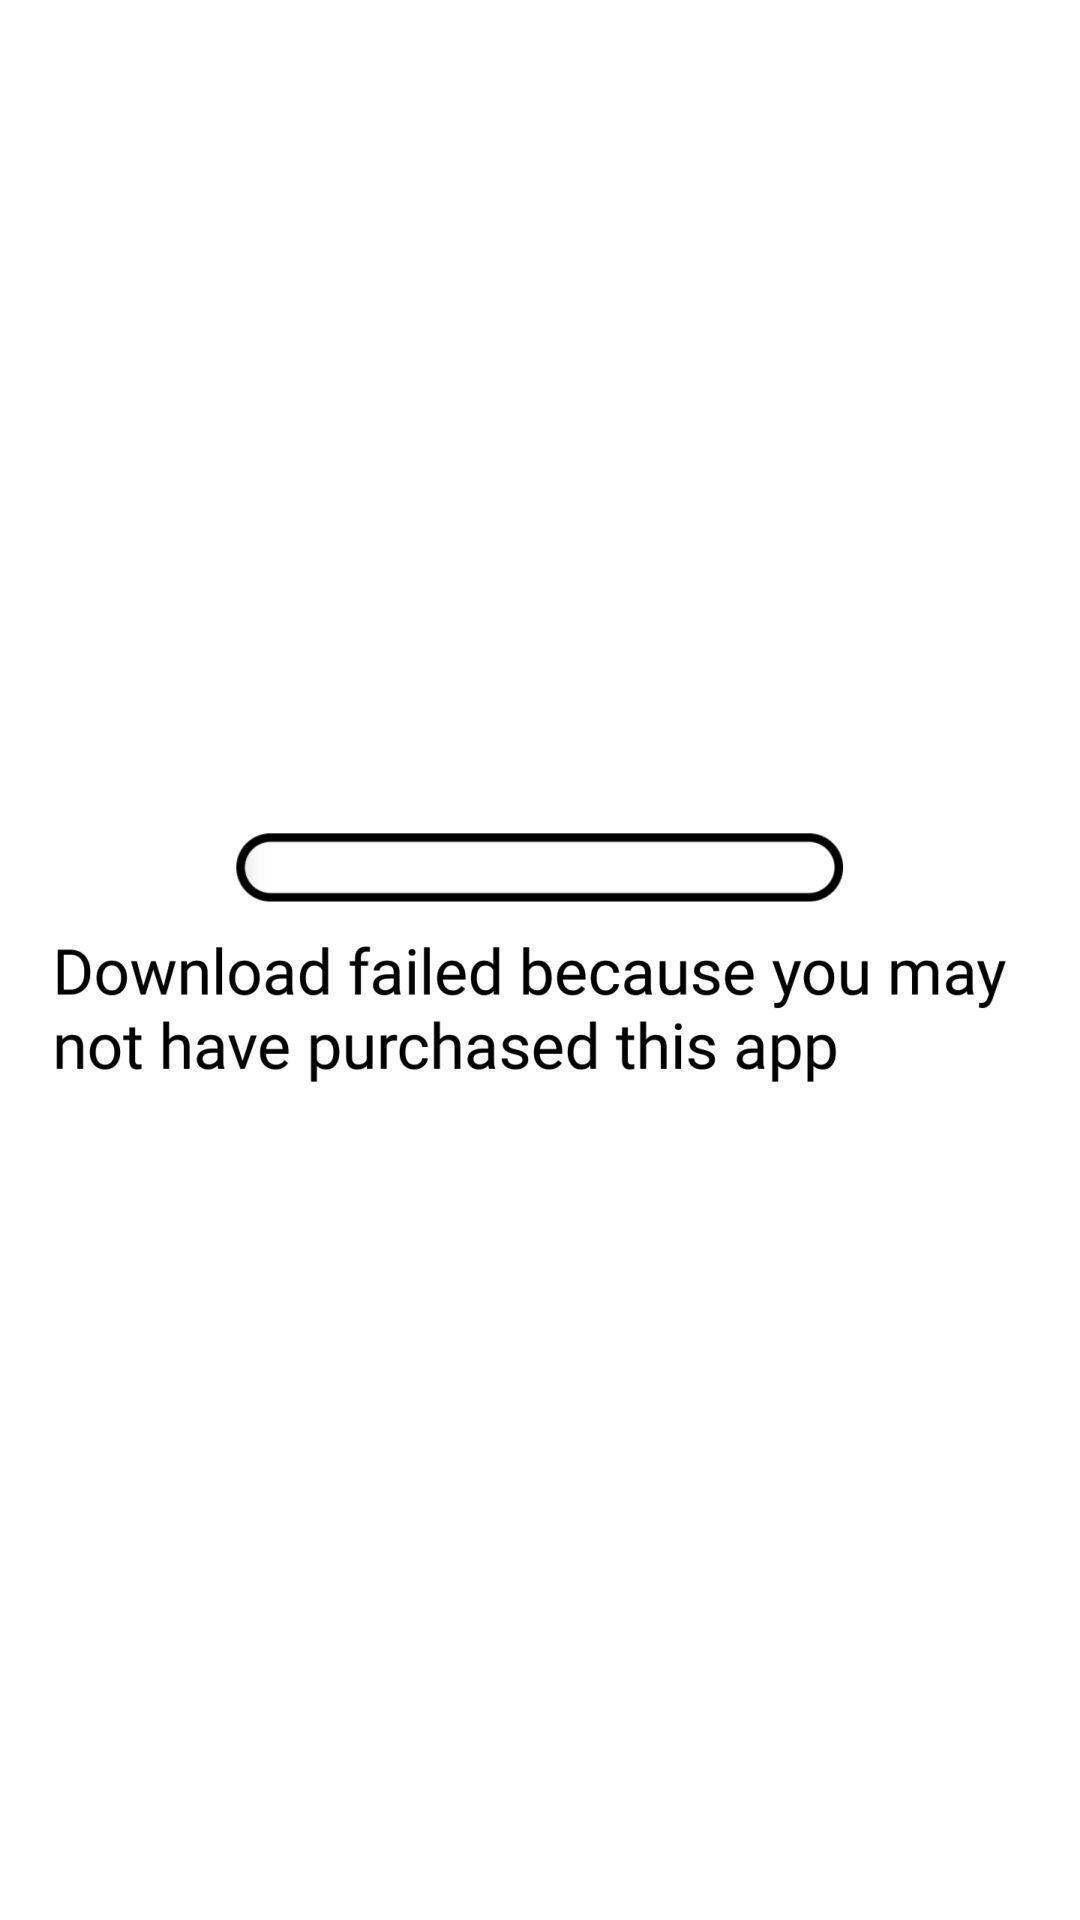Provide a textual representation of this image. Page showing the message of download failed. 